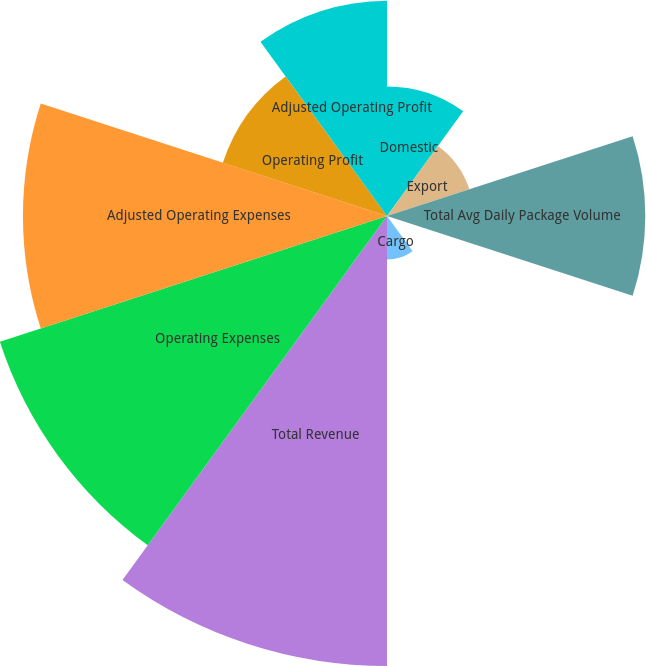<chart> <loc_0><loc_0><loc_500><loc_500><pie_chart><fcel>Domestic<fcel>Export<fcel>Total Avg Daily Package Volume<fcel>Total Avg Revenue Per Piece<fcel>Cargo<fcel>Total Revenue<fcel>Operating Expenses<fcel>Adjusted Operating Expenses<fcel>Operating Profit<fcel>Adjusted Operating Profit<nl><fcel>6.09%<fcel>4.07%<fcel>12.14%<fcel>0.03%<fcel>2.05%<fcel>21.15%<fcel>19.13%<fcel>17.11%<fcel>8.11%<fcel>10.12%<nl></chart> 